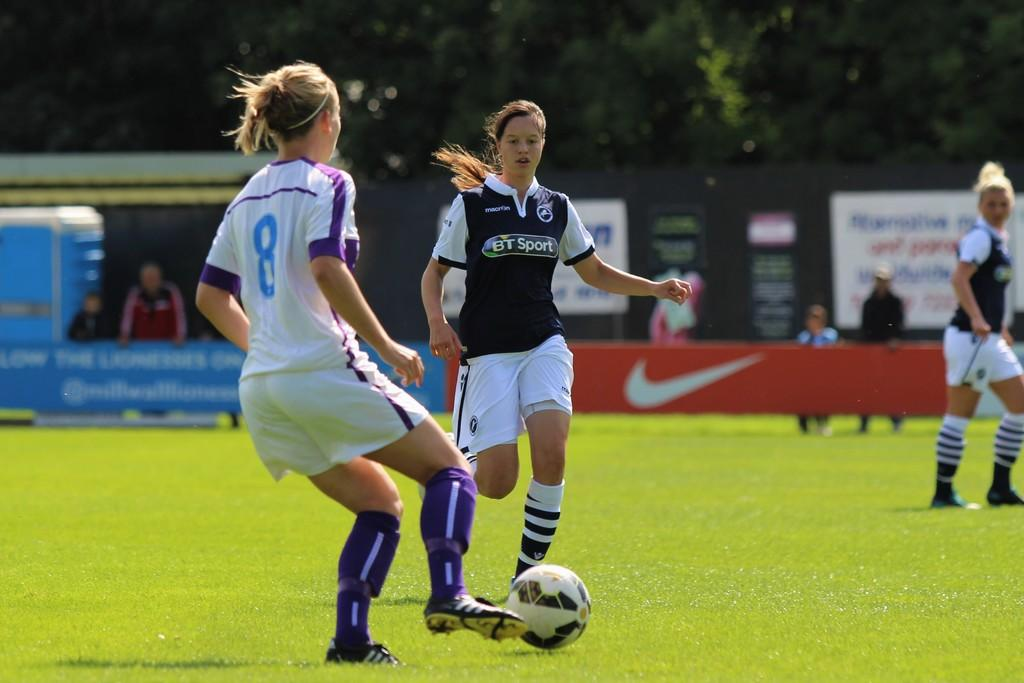Provide a one-sentence caption for the provided image. soccer players playing on a field with one wearing a jersey that says "BT Sport". 